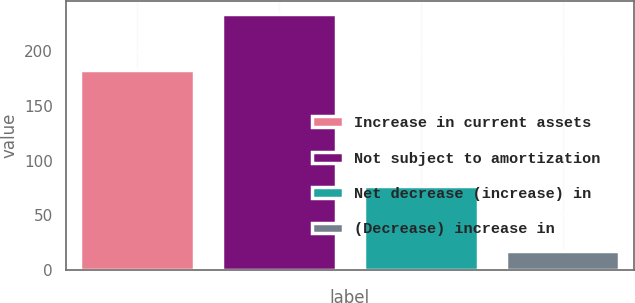Convert chart. <chart><loc_0><loc_0><loc_500><loc_500><bar_chart><fcel>Increase in current assets<fcel>Not subject to amortization<fcel>Net decrease (increase) in<fcel>(Decrease) increase in<nl><fcel>183<fcel>234<fcel>77<fcel>17<nl></chart> 